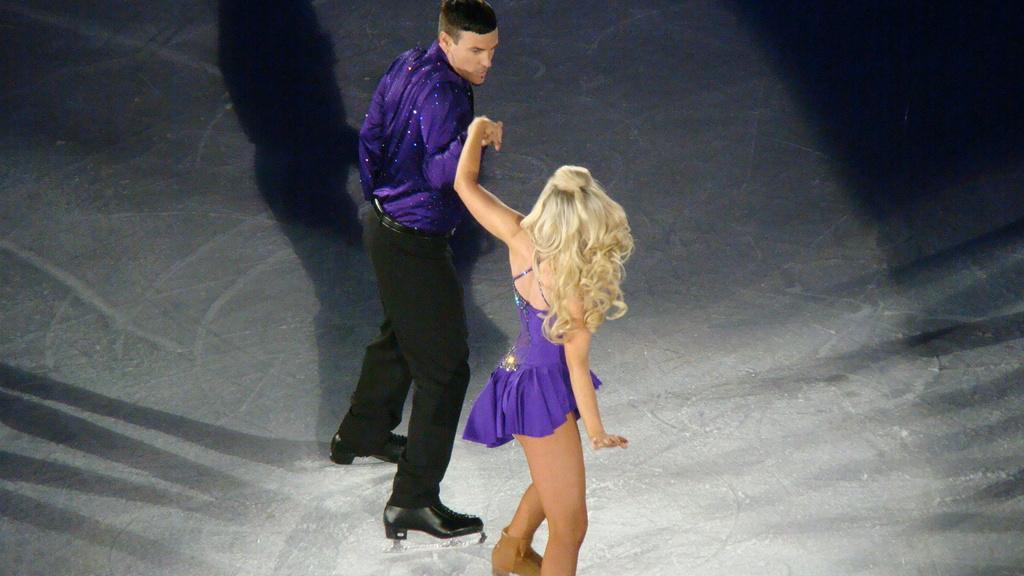In one or two sentences, can you explain what this image depicts? In this image we can see a man and a woman standing on the floor. On the floor we can see the shadow. 